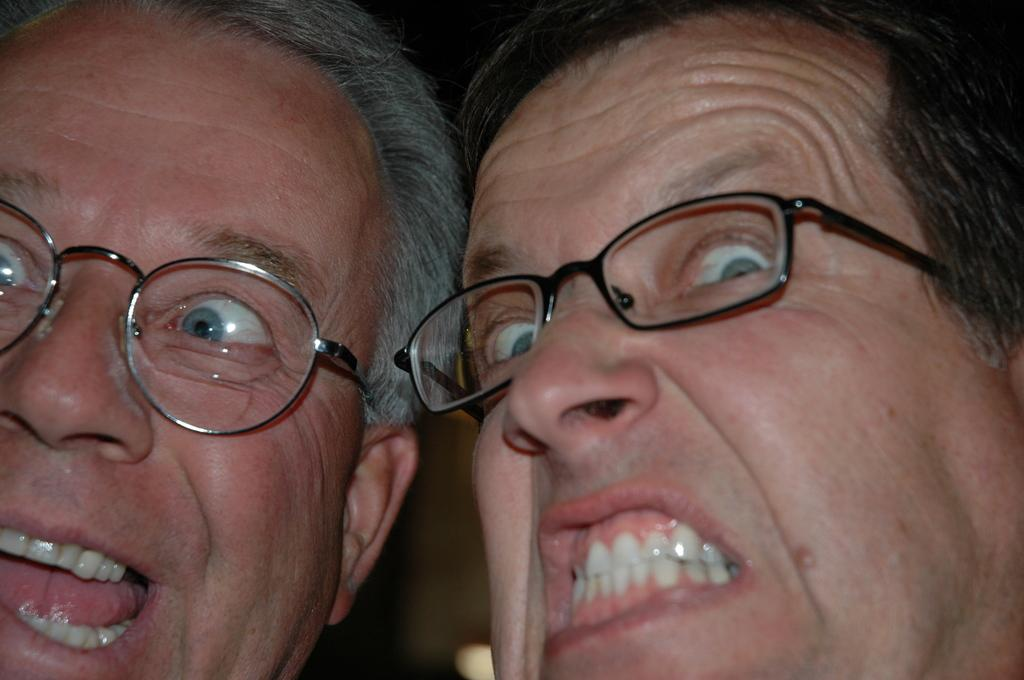How many people are in the image? There are two men in the image. What are the men doing in the image? The men are facing each other. What can be observed about the men's expressions or emotions? The men are showing their teeth, likely indicating expressions or smiles. What type of honey is being used by the zebra in the image? There is no zebra or honey present in the image; it features two men facing each other and showing their teeth. 